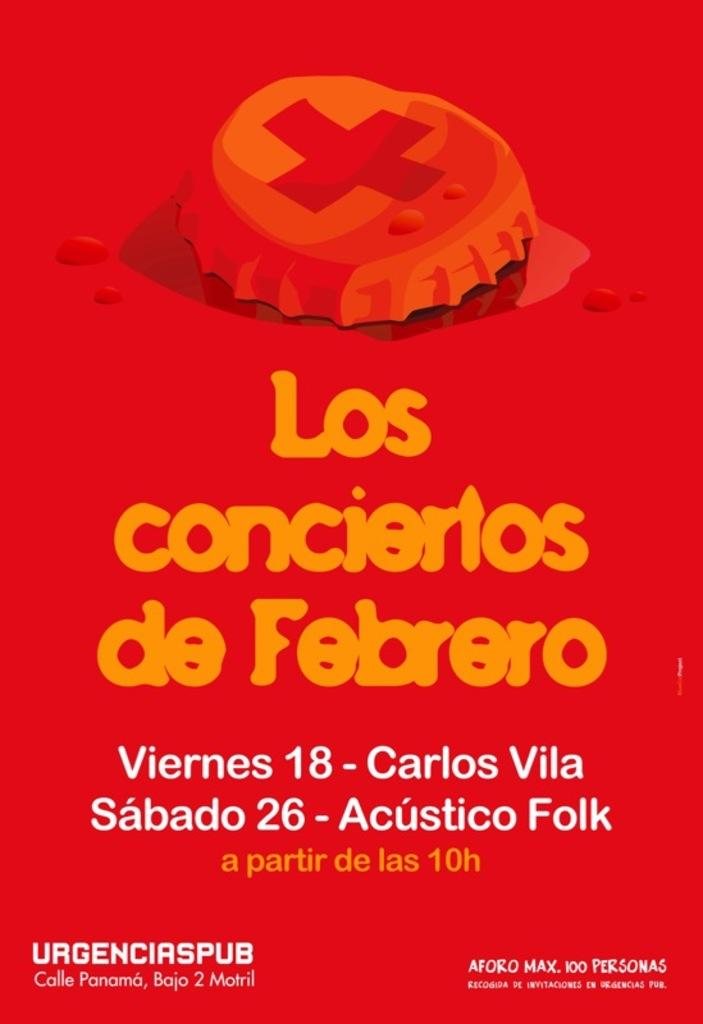What is present in the image that has text on it? There is a poster in the image that has text on it. Can you describe the poster in the image? The poster has text on it, but we cannot determine the specific content or design from the given facts. What type of bird can be seen giving birth in the image? There is no bird or any indication of birth in the image; it only features a poster with text on it. 